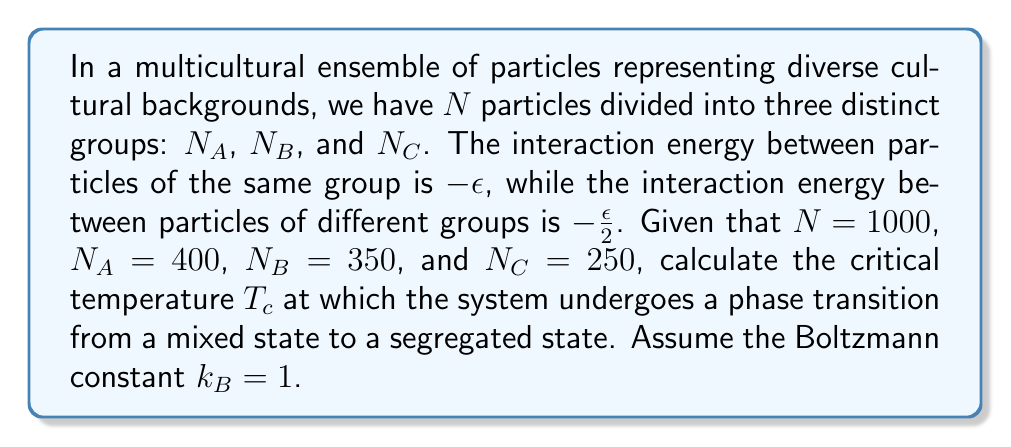What is the answer to this math problem? To solve this problem, we'll follow these steps:

1) In statistical mechanics, the critical temperature for phase transitions in such systems can be approximated using the mean-field theory. The critical temperature is given by:

   $$T_c = \frac{z\epsilon}{2k_B}$$

   where $z$ is the average number of nearest neighbors (coordination number).

2) In this multicultural ensemble, we need to consider the average interaction energy per particle. Let's call this $\bar{\epsilon}$:

   $$\bar{\epsilon} = \frac{1}{N} \left( -\epsilon \sum_{i} N_i^2 - \frac{\epsilon}{2} \sum_{i \neq j} N_i N_j \right)$$

3) Substituting the given values:

   $$\bar{\epsilon} = -\frac{\epsilon}{1000} (400^2 + 350^2 + 250^2 + \frac{1}{2}(400 \cdot 350 + 400 \cdot 250 + 350 \cdot 250) \cdot 2)$$

4) Simplifying:

   $$\bar{\epsilon} = -\frac{\epsilon}{1000} (160000 + 122500 + 62500 + 280000 + 200000 + 175000)$$
   $$\bar{\epsilon} = -\epsilon$$

5) This means that the average interaction energy is equivalent to the interaction energy within a single group. Therefore, we can use the standard mean-field approximation for the critical temperature:

   $$T_c = \frac{z\epsilon}{2k_B}$$

6) The coordination number $z$ depends on the lattice structure. For a simple cubic lattice, $z = 6$. Given $k_B = 1$, we have:

   $$T_c = \frac{6\epsilon}{2} = 3\epsilon$$

Thus, the critical temperature is $3\epsilon$, where $\epsilon$ is the interaction energy between particles of the same group.
Answer: $T_c = 3\epsilon$ 